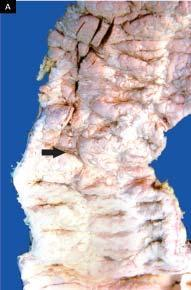did broad base contain necrotic tissue?
Answer the question using a single word or phrase. Yes 